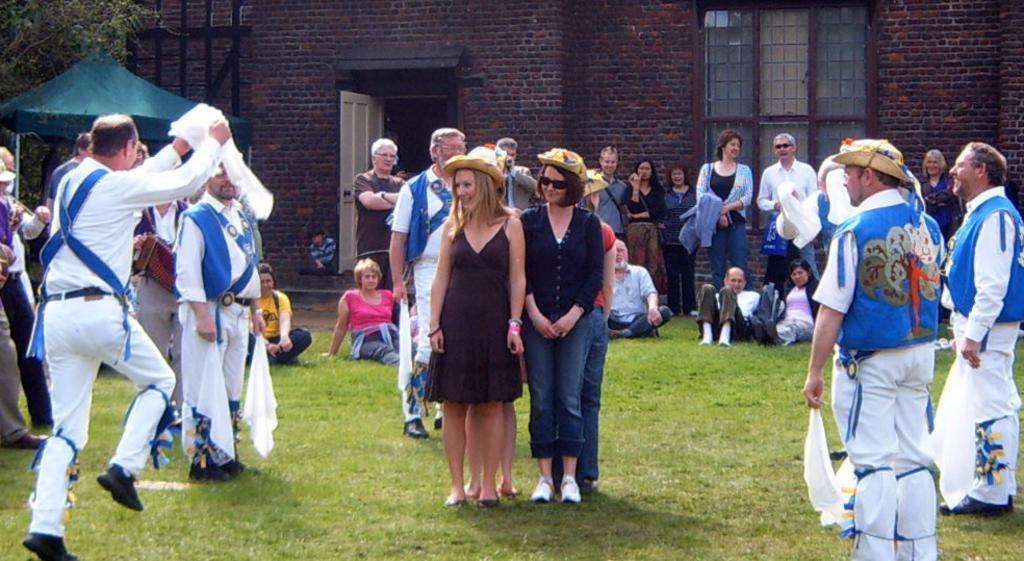Describe this image in one or two sentences. In front of the picture, we see two women are standing. They are smiling. Behind them, we see the people are standing and few of them are sitting on the grass. At the bottom, we see the grass. On the left side, we see a man in the white shirt is holding a white cloth in his hand. He is running. On the left side, we see a green color tint. Beside that, we see a tree. In the background, we see a building which is made up of bricks. It has windows and a white door. 